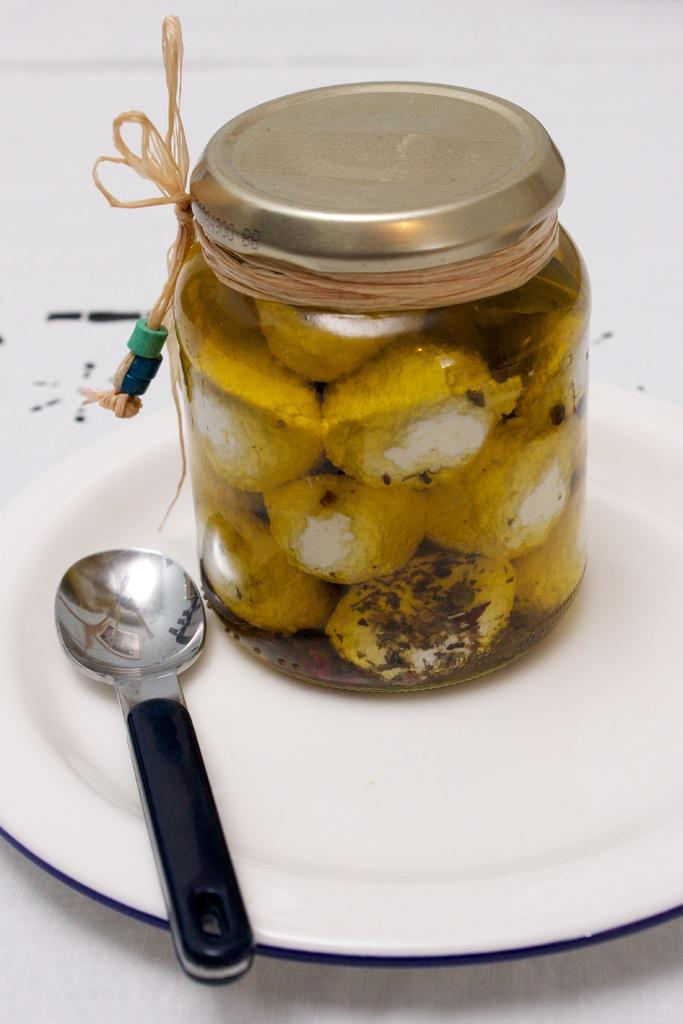What is on the table in the image? There is a plate on the table. What is on the plate? There is a spoon and a jar on the plate. How is the jar secured on the plate? The jar is tied with a thread. What type of pail is used for watering plants on the stage in the image? There is no pail, watering plants, or stage present in the image. 